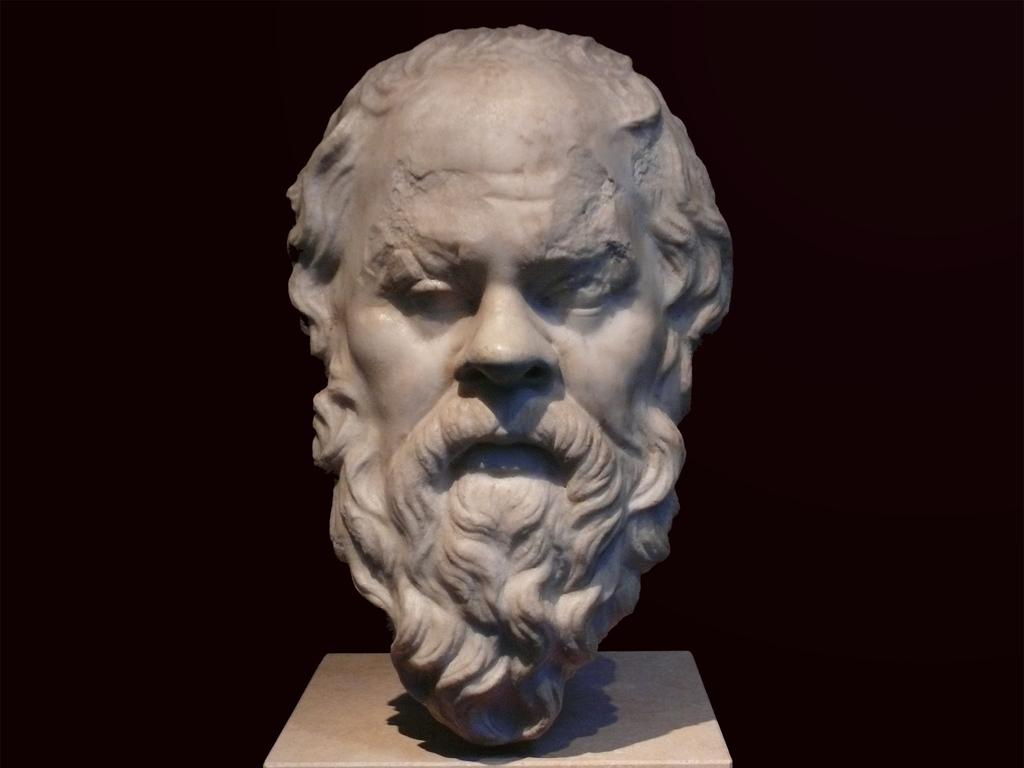What is the main subject of the image? The main subject of the image is a sculpture on a pillar. Can you describe the sculpture? The sculpture has the face of a man. What can be observed about the background of the image? The background of the image is dark. What type of bean is being used to create the route in the image? There is no bean or route present in the image; it features a sculpture with the face of a man on a pillar. 